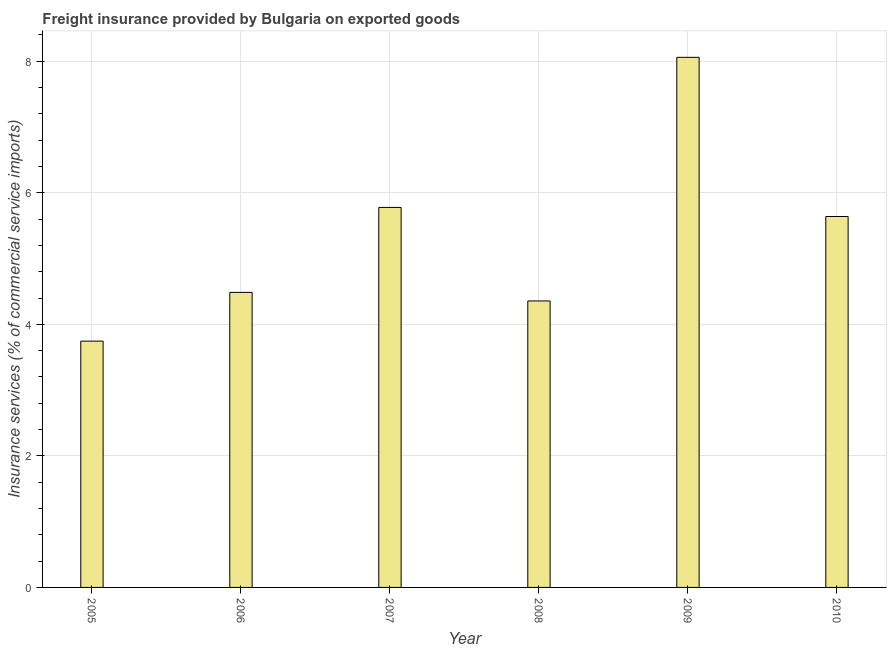Does the graph contain any zero values?
Provide a succinct answer. No. What is the title of the graph?
Ensure brevity in your answer.  Freight insurance provided by Bulgaria on exported goods . What is the label or title of the X-axis?
Your response must be concise. Year. What is the label or title of the Y-axis?
Offer a very short reply. Insurance services (% of commercial service imports). What is the freight insurance in 2010?
Your response must be concise. 5.64. Across all years, what is the maximum freight insurance?
Provide a succinct answer. 8.06. Across all years, what is the minimum freight insurance?
Provide a short and direct response. 3.75. In which year was the freight insurance minimum?
Keep it short and to the point. 2005. What is the sum of the freight insurance?
Your answer should be very brief. 32.07. What is the difference between the freight insurance in 2009 and 2010?
Keep it short and to the point. 2.42. What is the average freight insurance per year?
Provide a succinct answer. 5.34. What is the median freight insurance?
Provide a succinct answer. 5.06. Do a majority of the years between 2008 and 2005 (inclusive) have freight insurance greater than 3.2 %?
Ensure brevity in your answer.  Yes. What is the ratio of the freight insurance in 2009 to that in 2010?
Offer a terse response. 1.43. Is the freight insurance in 2005 less than that in 2008?
Give a very brief answer. Yes. Is the difference between the freight insurance in 2005 and 2010 greater than the difference between any two years?
Offer a terse response. No. What is the difference between the highest and the second highest freight insurance?
Offer a terse response. 2.28. Is the sum of the freight insurance in 2005 and 2007 greater than the maximum freight insurance across all years?
Offer a terse response. Yes. What is the difference between the highest and the lowest freight insurance?
Your answer should be compact. 4.31. Are all the bars in the graph horizontal?
Your answer should be very brief. No. How many years are there in the graph?
Provide a short and direct response. 6. What is the difference between two consecutive major ticks on the Y-axis?
Make the answer very short. 2. Are the values on the major ticks of Y-axis written in scientific E-notation?
Give a very brief answer. No. What is the Insurance services (% of commercial service imports) of 2005?
Your answer should be compact. 3.75. What is the Insurance services (% of commercial service imports) of 2006?
Offer a terse response. 4.49. What is the Insurance services (% of commercial service imports) in 2007?
Provide a short and direct response. 5.78. What is the Insurance services (% of commercial service imports) of 2008?
Give a very brief answer. 4.36. What is the Insurance services (% of commercial service imports) in 2009?
Your answer should be very brief. 8.06. What is the Insurance services (% of commercial service imports) in 2010?
Make the answer very short. 5.64. What is the difference between the Insurance services (% of commercial service imports) in 2005 and 2006?
Provide a short and direct response. -0.74. What is the difference between the Insurance services (% of commercial service imports) in 2005 and 2007?
Provide a succinct answer. -2.03. What is the difference between the Insurance services (% of commercial service imports) in 2005 and 2008?
Offer a very short reply. -0.61. What is the difference between the Insurance services (% of commercial service imports) in 2005 and 2009?
Keep it short and to the point. -4.31. What is the difference between the Insurance services (% of commercial service imports) in 2005 and 2010?
Offer a very short reply. -1.89. What is the difference between the Insurance services (% of commercial service imports) in 2006 and 2007?
Ensure brevity in your answer.  -1.29. What is the difference between the Insurance services (% of commercial service imports) in 2006 and 2008?
Your answer should be very brief. 0.13. What is the difference between the Insurance services (% of commercial service imports) in 2006 and 2009?
Ensure brevity in your answer.  -3.57. What is the difference between the Insurance services (% of commercial service imports) in 2006 and 2010?
Provide a short and direct response. -1.15. What is the difference between the Insurance services (% of commercial service imports) in 2007 and 2008?
Your answer should be compact. 1.42. What is the difference between the Insurance services (% of commercial service imports) in 2007 and 2009?
Offer a terse response. -2.28. What is the difference between the Insurance services (% of commercial service imports) in 2007 and 2010?
Provide a short and direct response. 0.14. What is the difference between the Insurance services (% of commercial service imports) in 2008 and 2009?
Ensure brevity in your answer.  -3.7. What is the difference between the Insurance services (% of commercial service imports) in 2008 and 2010?
Make the answer very short. -1.28. What is the difference between the Insurance services (% of commercial service imports) in 2009 and 2010?
Offer a very short reply. 2.42. What is the ratio of the Insurance services (% of commercial service imports) in 2005 to that in 2006?
Ensure brevity in your answer.  0.83. What is the ratio of the Insurance services (% of commercial service imports) in 2005 to that in 2007?
Give a very brief answer. 0.65. What is the ratio of the Insurance services (% of commercial service imports) in 2005 to that in 2008?
Your answer should be compact. 0.86. What is the ratio of the Insurance services (% of commercial service imports) in 2005 to that in 2009?
Keep it short and to the point. 0.47. What is the ratio of the Insurance services (% of commercial service imports) in 2005 to that in 2010?
Provide a succinct answer. 0.66. What is the ratio of the Insurance services (% of commercial service imports) in 2006 to that in 2007?
Make the answer very short. 0.78. What is the ratio of the Insurance services (% of commercial service imports) in 2006 to that in 2009?
Your answer should be very brief. 0.56. What is the ratio of the Insurance services (% of commercial service imports) in 2006 to that in 2010?
Give a very brief answer. 0.8. What is the ratio of the Insurance services (% of commercial service imports) in 2007 to that in 2008?
Offer a terse response. 1.33. What is the ratio of the Insurance services (% of commercial service imports) in 2007 to that in 2009?
Provide a short and direct response. 0.72. What is the ratio of the Insurance services (% of commercial service imports) in 2008 to that in 2009?
Provide a short and direct response. 0.54. What is the ratio of the Insurance services (% of commercial service imports) in 2008 to that in 2010?
Your response must be concise. 0.77. What is the ratio of the Insurance services (% of commercial service imports) in 2009 to that in 2010?
Make the answer very short. 1.43. 